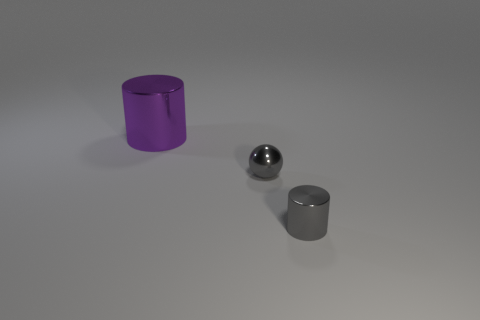Add 2 big balls. How many objects exist? 5 Subtract all cylinders. How many objects are left? 1 Subtract all things. Subtract all big red metal cylinders. How many objects are left? 0 Add 3 large metallic objects. How many large metallic objects are left? 4 Add 3 tiny blue things. How many tiny blue things exist? 3 Subtract 0 brown spheres. How many objects are left? 3 